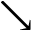<formula> <loc_0><loc_0><loc_500><loc_500>\searrow</formula> 